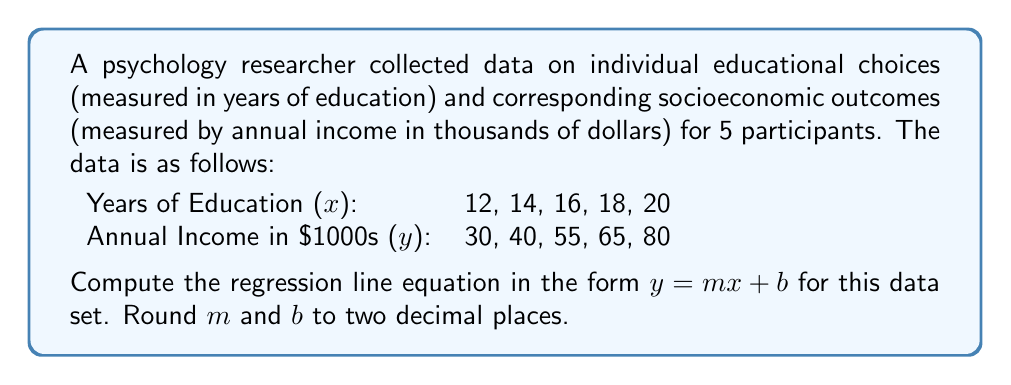What is the answer to this math problem? To compute the regression line, we'll use the least squares method. The steps are:

1. Calculate the means of x and y:
   $\bar{x} = \frac{12 + 14 + 16 + 18 + 20}{5} = 16$
   $\bar{y} = \frac{30 + 40 + 55 + 65 + 80}{5} = 54$

2. Calculate $\sum (x - \bar{x})(y - \bar{y})$ and $\sum (x - \bar{x})^2$:
   $\sum (x - \bar{x})(y - \bar{y}) = (-4)(-24) + (-2)(-14) + (0)(1) + (2)(11) + (4)(26) = 96 + 28 + 0 + 22 + 104 = 250$
   $\sum (x - \bar{x})^2 = (-4)^2 + (-2)^2 + (0)^2 + (2)^2 + (4)^2 = 16 + 4 + 0 + 4 + 16 = 40$

3. Calculate the slope (m):
   $m = \frac{\sum (x - \bar{x})(y - \bar{y})}{\sum (x - \bar{x})^2} = \frac{250}{40} = 6.25$

4. Calculate the y-intercept (b):
   $b = \bar{y} - m\bar{x} = 54 - 6.25(16) = -46$

5. Round m and b to two decimal places:
   $m = 6.25$
   $b = -46.00$

Therefore, the regression line equation is $y = 6.25x - 46.00$.
Answer: $y = 6.25x - 46.00$ 